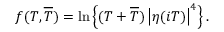<formula> <loc_0><loc_0><loc_500><loc_500>f ( T , \overline { T } ) = \ln \left \{ ( T + \overline { T } ) \left | \eta ( i T ) \right | ^ { 4 } \right \} .</formula> 